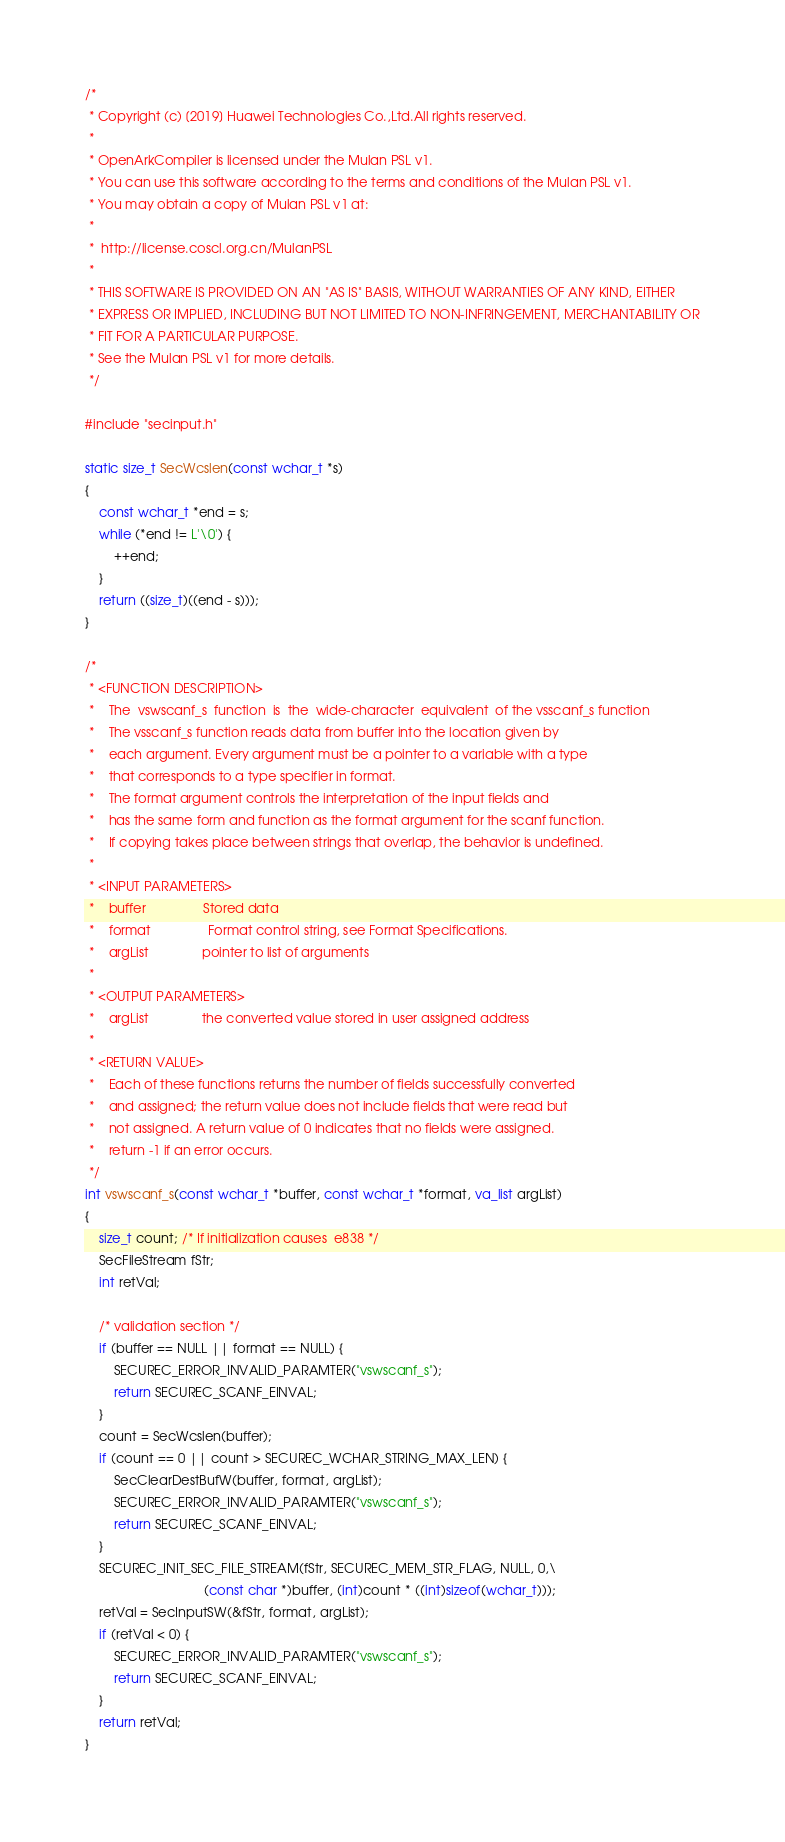Convert code to text. <code><loc_0><loc_0><loc_500><loc_500><_C_>/*
 * Copyright (c) [2019] Huawei Technologies Co.,Ltd.All rights reserved.
 *
 * OpenArkCompiler is licensed under the Mulan PSL v1. 
 * You can use this software according to the terms and conditions of the Mulan PSL v1.
 * You may obtain a copy of Mulan PSL v1 at:
 *
 * 	http://license.coscl.org.cn/MulanPSL 
 *
 * THIS SOFTWARE IS PROVIDED ON AN "AS IS" BASIS, WITHOUT WARRANTIES OF ANY KIND, EITHER 
 * EXPRESS OR IMPLIED, INCLUDING BUT NOT LIMITED TO NON-INFRINGEMENT, MERCHANTABILITY OR
 * FIT FOR A PARTICULAR PURPOSE.  
 * See the Mulan PSL v1 for more details.  
 */

#include "secinput.h"

static size_t SecWcslen(const wchar_t *s)
{
    const wchar_t *end = s;
    while (*end != L'\0') {
        ++end;
    }
    return ((size_t)((end - s)));
}

/*
 * <FUNCTION DESCRIPTION>
 *    The  vswscanf_s  function  is  the  wide-character  equivalent  of the vsscanf_s function
 *    The vsscanf_s function reads data from buffer into the location given by
 *    each argument. Every argument must be a pointer to a variable with a type
 *    that corresponds to a type specifier in format.
 *    The format argument controls the interpretation of the input fields and
 *    has the same form and function as the format argument for the scanf function.
 *    If copying takes place between strings that overlap, the behavior is undefined.
 *
 * <INPUT PARAMETERS>
 *    buffer                Stored data
 *    format                Format control string, see Format Specifications.
 *    argList               pointer to list of arguments
 *
 * <OUTPUT PARAMETERS>
 *    argList               the converted value stored in user assigned address
 *
 * <RETURN VALUE>
 *    Each of these functions returns the number of fields successfully converted
 *    and assigned; the return value does not include fields that were read but
 *    not assigned. A return value of 0 indicates that no fields were assigned.
 *    return -1 if an error occurs.
 */
int vswscanf_s(const wchar_t *buffer, const wchar_t *format, va_list argList)
{
    size_t count; /* If initialization causes  e838 */
    SecFileStream fStr;
    int retVal;

    /* validation section */
    if (buffer == NULL || format == NULL) {
        SECUREC_ERROR_INVALID_PARAMTER("vswscanf_s");
        return SECUREC_SCANF_EINVAL;
    }
    count = SecWcslen(buffer);
    if (count == 0 || count > SECUREC_WCHAR_STRING_MAX_LEN) {
        SecClearDestBufW(buffer, format, argList);
        SECUREC_ERROR_INVALID_PARAMTER("vswscanf_s");
        return SECUREC_SCANF_EINVAL;
    }
    SECUREC_INIT_SEC_FILE_STREAM(fStr, SECUREC_MEM_STR_FLAG, NULL, 0,\
                                 (const char *)buffer, (int)count * ((int)sizeof(wchar_t)));
    retVal = SecInputSW(&fStr, format, argList);
    if (retVal < 0) {
        SECUREC_ERROR_INVALID_PARAMTER("vswscanf_s");
        return SECUREC_SCANF_EINVAL;
    }
    return retVal;
}


</code> 